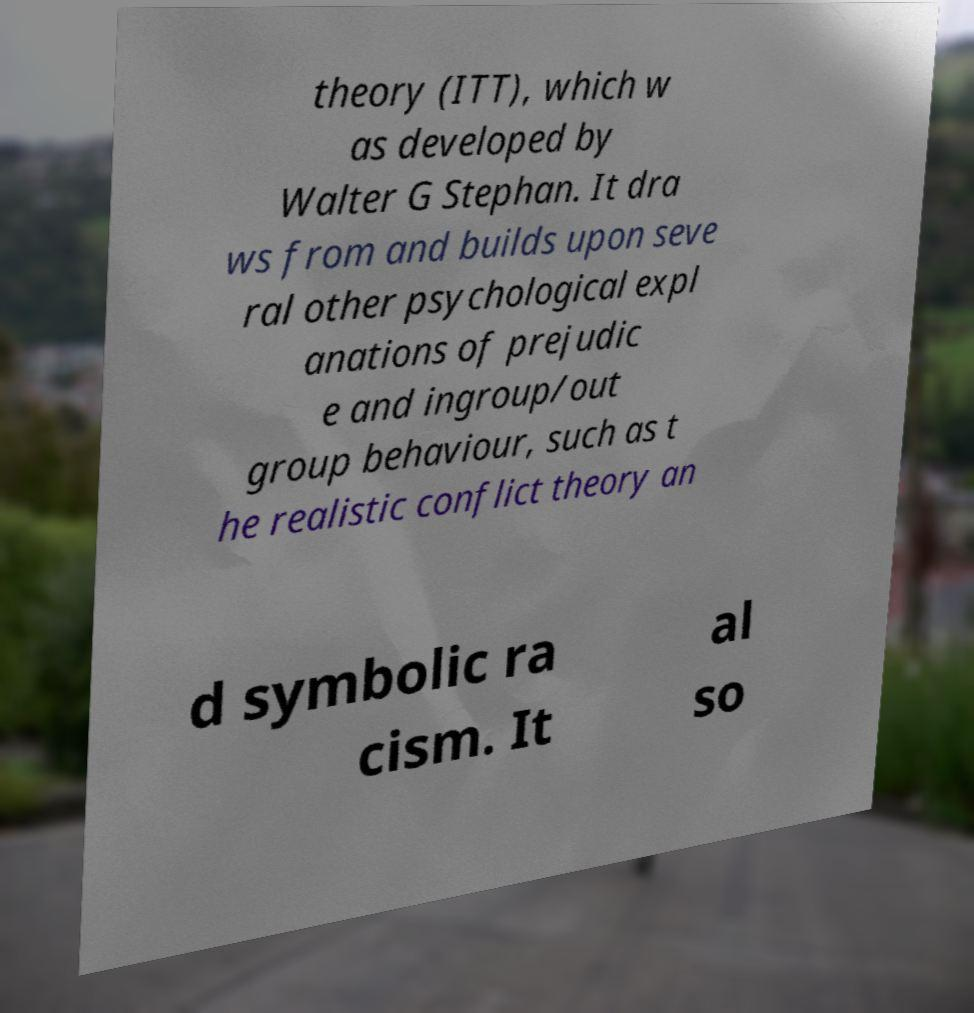Can you read and provide the text displayed in the image?This photo seems to have some interesting text. Can you extract and type it out for me? theory (ITT), which w as developed by Walter G Stephan. It dra ws from and builds upon seve ral other psychological expl anations of prejudic e and ingroup/out group behaviour, such as t he realistic conflict theory an d symbolic ra cism. It al so 